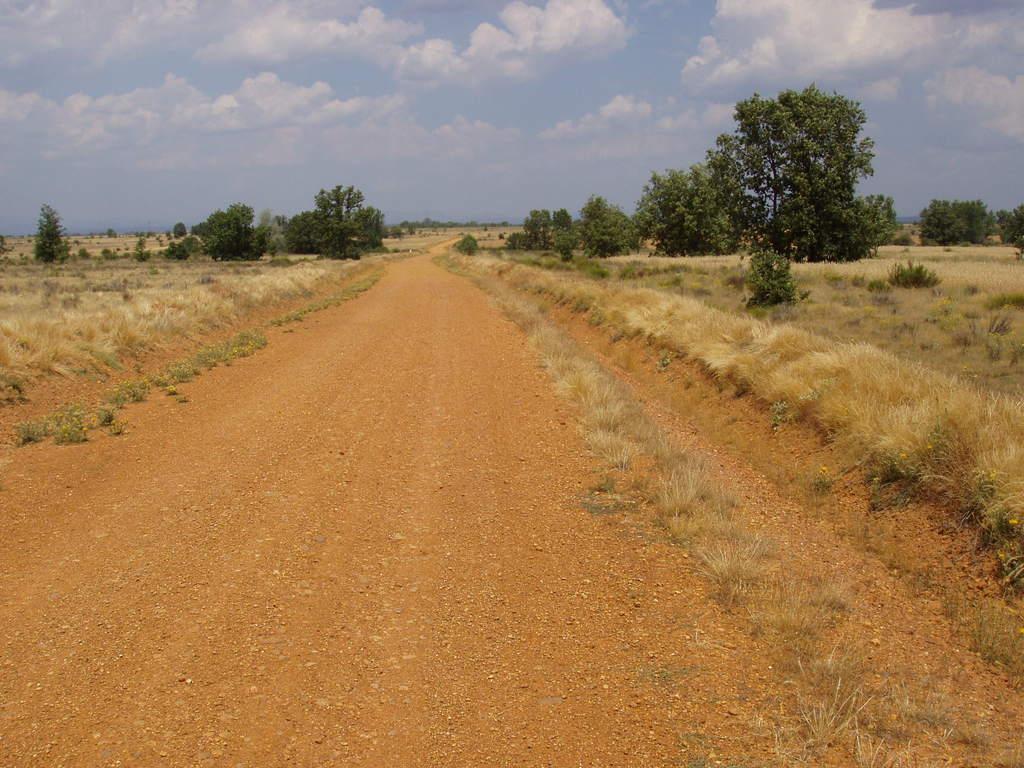What type of vegetation is present in the image? There are many trees in the image. What else can be seen on the ground in the image? There is grass in the image. What is visible in the sky in the image? The sky is visible in the image with clouds. What type of pathway is present at the bottom of the image? There is a road at the bottom of the image. How long does it take for the minute hand to complete one rotation in the image? There is no clock or any indication of time in the image, so it is not possible to determine the movement of a minute hand. 